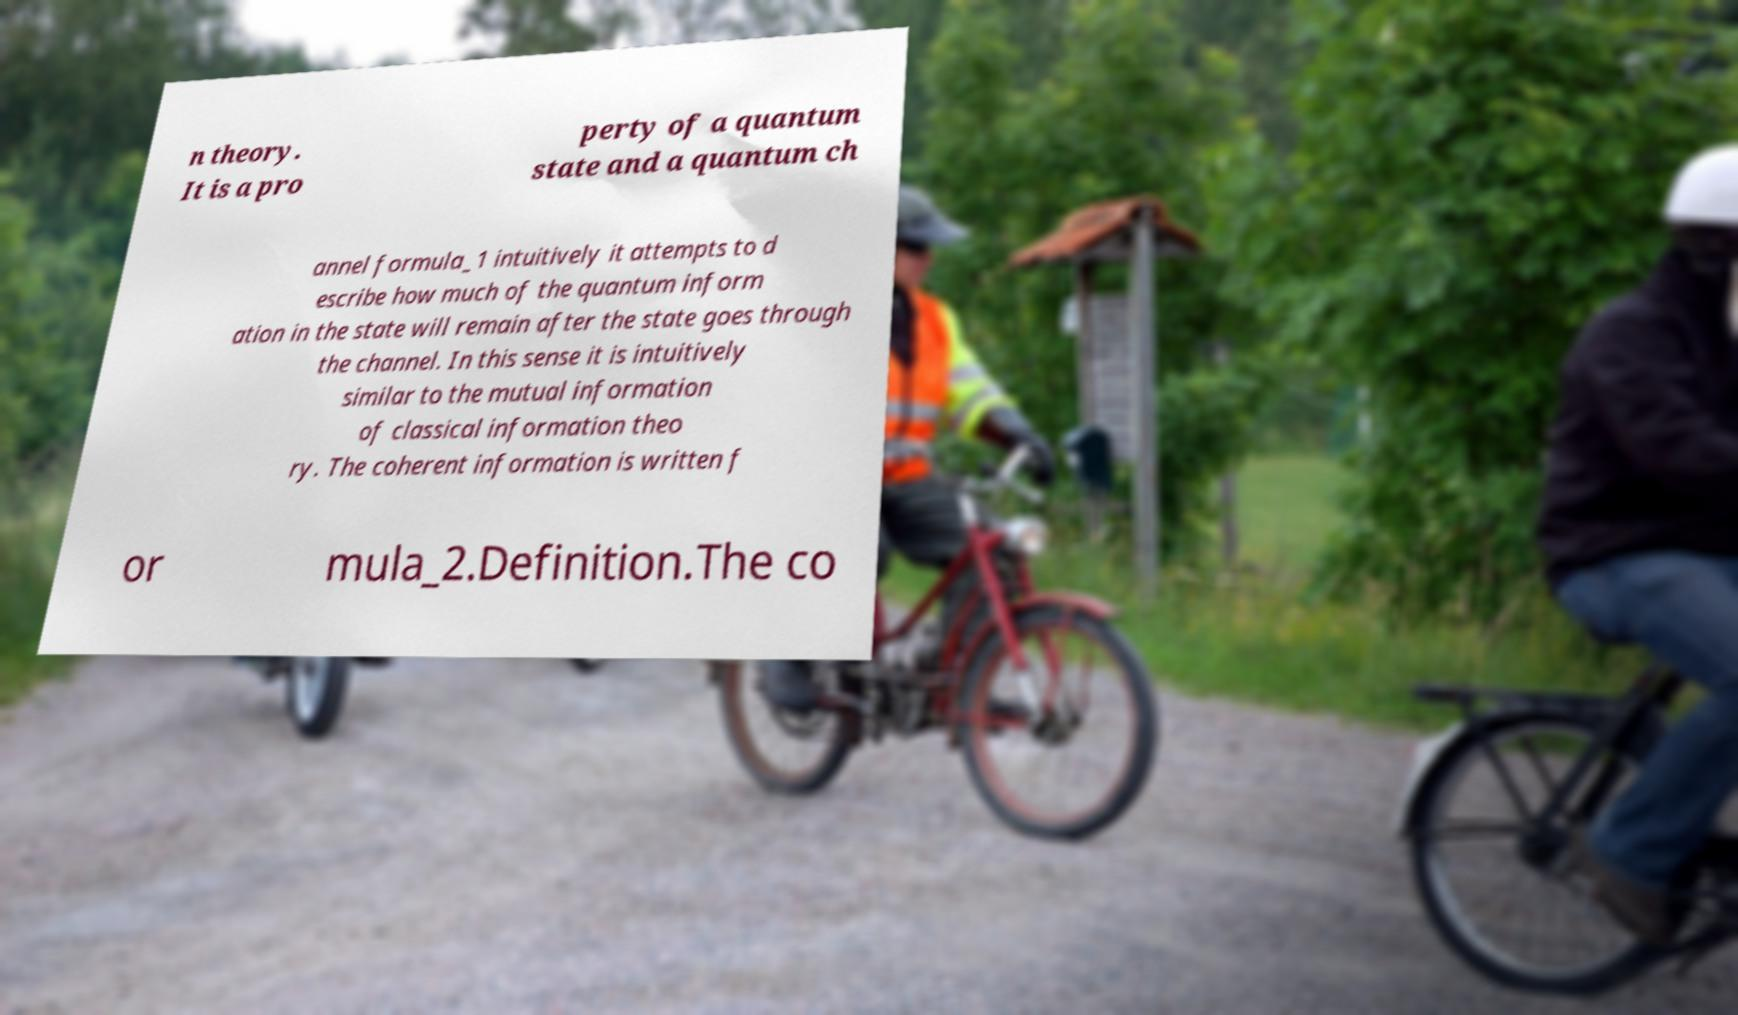What messages or text are displayed in this image? I need them in a readable, typed format. n theory. It is a pro perty of a quantum state and a quantum ch annel formula_1 intuitively it attempts to d escribe how much of the quantum inform ation in the state will remain after the state goes through the channel. In this sense it is intuitively similar to the mutual information of classical information theo ry. The coherent information is written f or mula_2.Definition.The co 